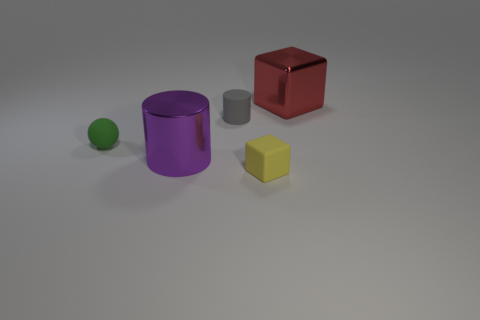Add 3 cyan objects. How many objects exist? 8 Subtract all balls. How many objects are left? 4 Subtract all gray matte objects. Subtract all yellow matte cubes. How many objects are left? 3 Add 5 red cubes. How many red cubes are left? 6 Add 5 red spheres. How many red spheres exist? 5 Subtract 1 yellow blocks. How many objects are left? 4 